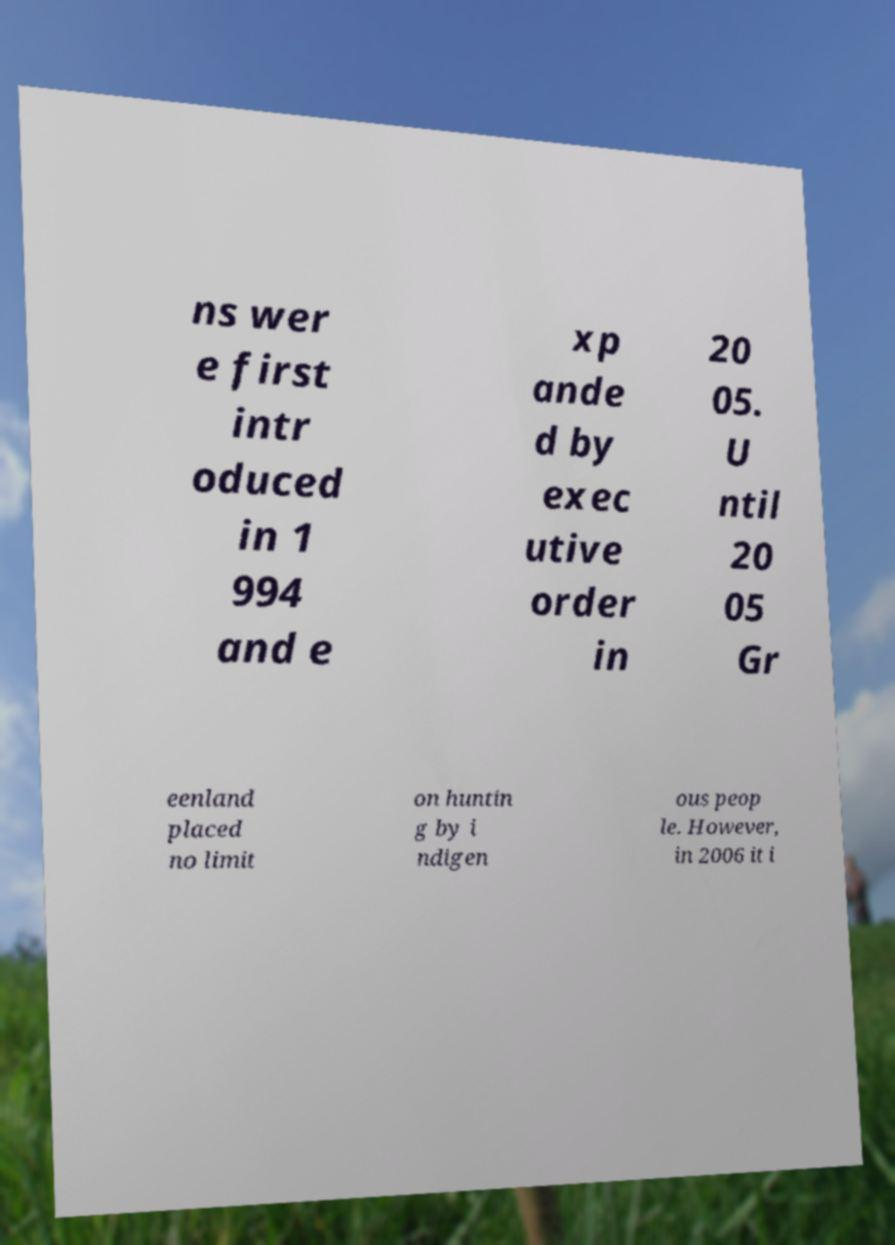For documentation purposes, I need the text within this image transcribed. Could you provide that? ns wer e first intr oduced in 1 994 and e xp ande d by exec utive order in 20 05. U ntil 20 05 Gr eenland placed no limit on huntin g by i ndigen ous peop le. However, in 2006 it i 